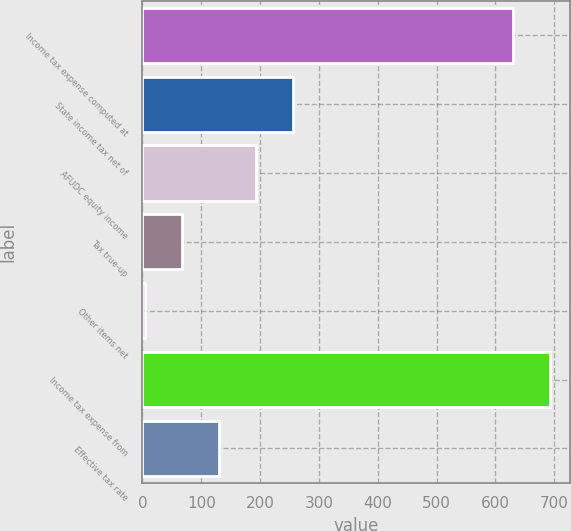<chart> <loc_0><loc_0><loc_500><loc_500><bar_chart><fcel>Income tax expense computed at<fcel>State income tax net of<fcel>AFUDC equity income<fcel>Tax true-up<fcel>Other items net<fcel>Income tax expense from<fcel>Effective tax rate<nl><fcel>630<fcel>256.6<fcel>193.7<fcel>67.9<fcel>5<fcel>692.9<fcel>130.8<nl></chart> 